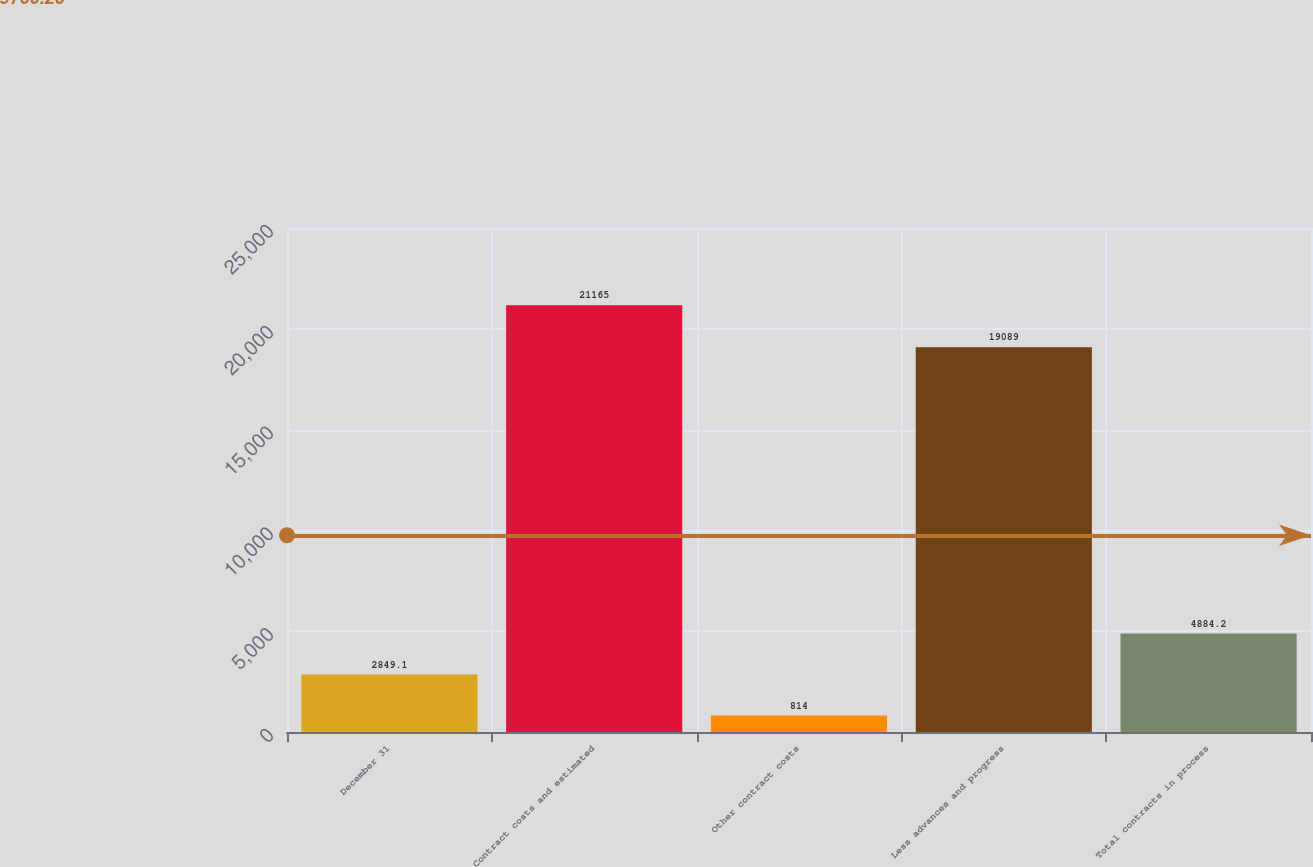Convert chart to OTSL. <chart><loc_0><loc_0><loc_500><loc_500><bar_chart><fcel>December 31<fcel>Contract costs and estimated<fcel>Other contract costs<fcel>Less advances and progress<fcel>Total contracts in process<nl><fcel>2849.1<fcel>21165<fcel>814<fcel>19089<fcel>4884.2<nl></chart> 